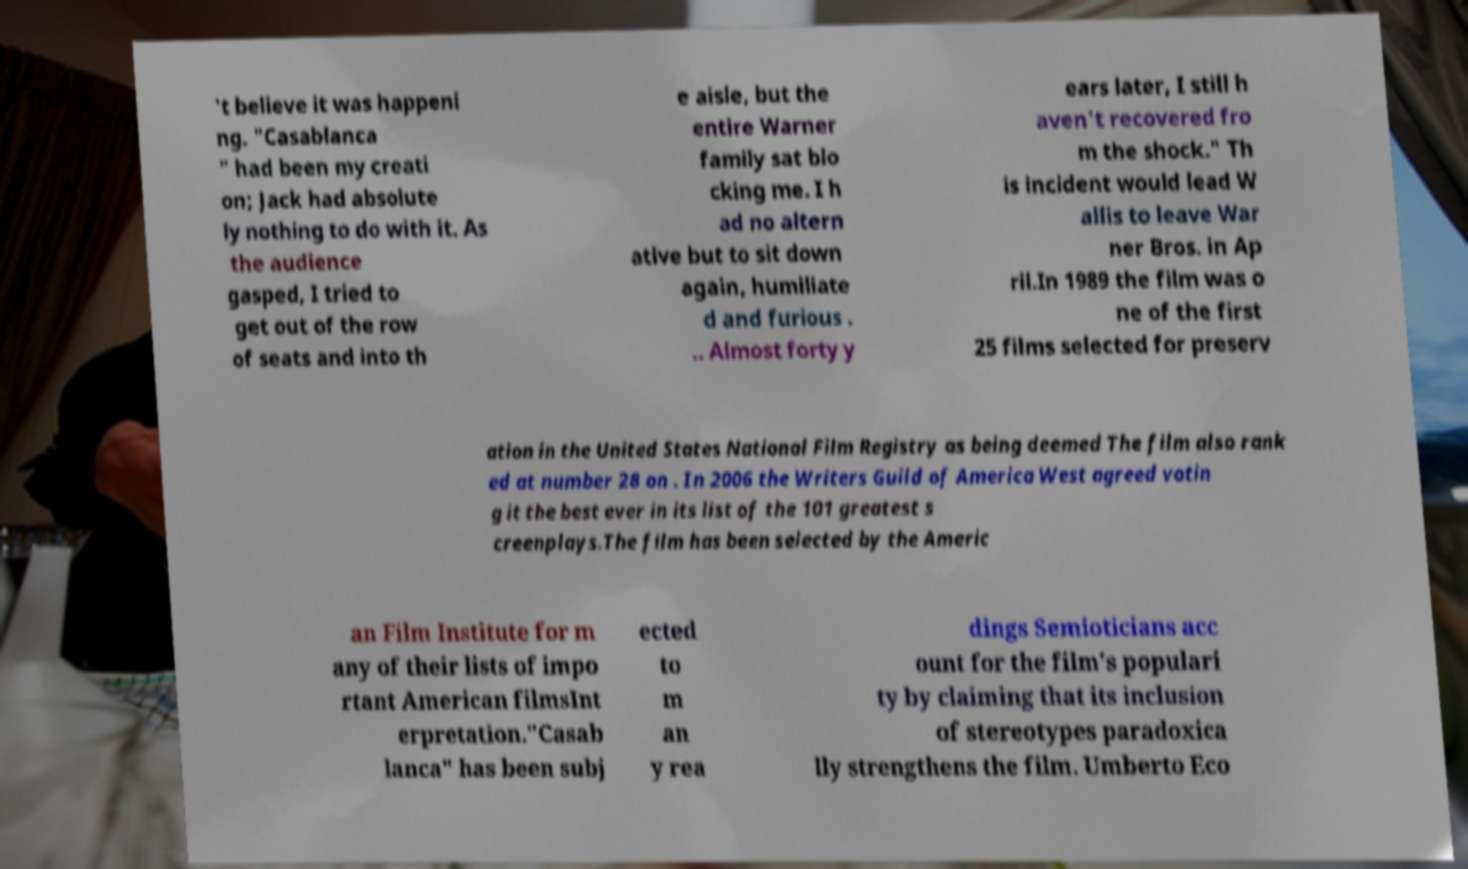Can you accurately transcribe the text from the provided image for me? 't believe it was happeni ng. "Casablanca " had been my creati on; Jack had absolute ly nothing to do with it. As the audience gasped, I tried to get out of the row of seats and into th e aisle, but the entire Warner family sat blo cking me. I h ad no altern ative but to sit down again, humiliate d and furious . .. Almost forty y ears later, I still h aven't recovered fro m the shock." Th is incident would lead W allis to leave War ner Bros. in Ap ril.In 1989 the film was o ne of the first 25 films selected for preserv ation in the United States National Film Registry as being deemed The film also rank ed at number 28 on . In 2006 the Writers Guild of America West agreed votin g it the best ever in its list of the 101 greatest s creenplays.The film has been selected by the Americ an Film Institute for m any of their lists of impo rtant American filmsInt erpretation."Casab lanca" has been subj ected to m an y rea dings Semioticians acc ount for the film's populari ty by claiming that its inclusion of stereotypes paradoxica lly strengthens the film. Umberto Eco 